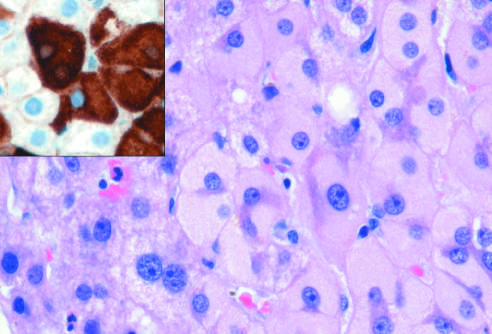what shows the presence of abundant, finely granular pink cytoplasmic inclusions?
Answer the question using a single word or phrase. Hematoxylin-eosin staining 